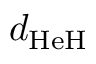<formula> <loc_0><loc_0><loc_500><loc_500>d _ { H e H }</formula> 